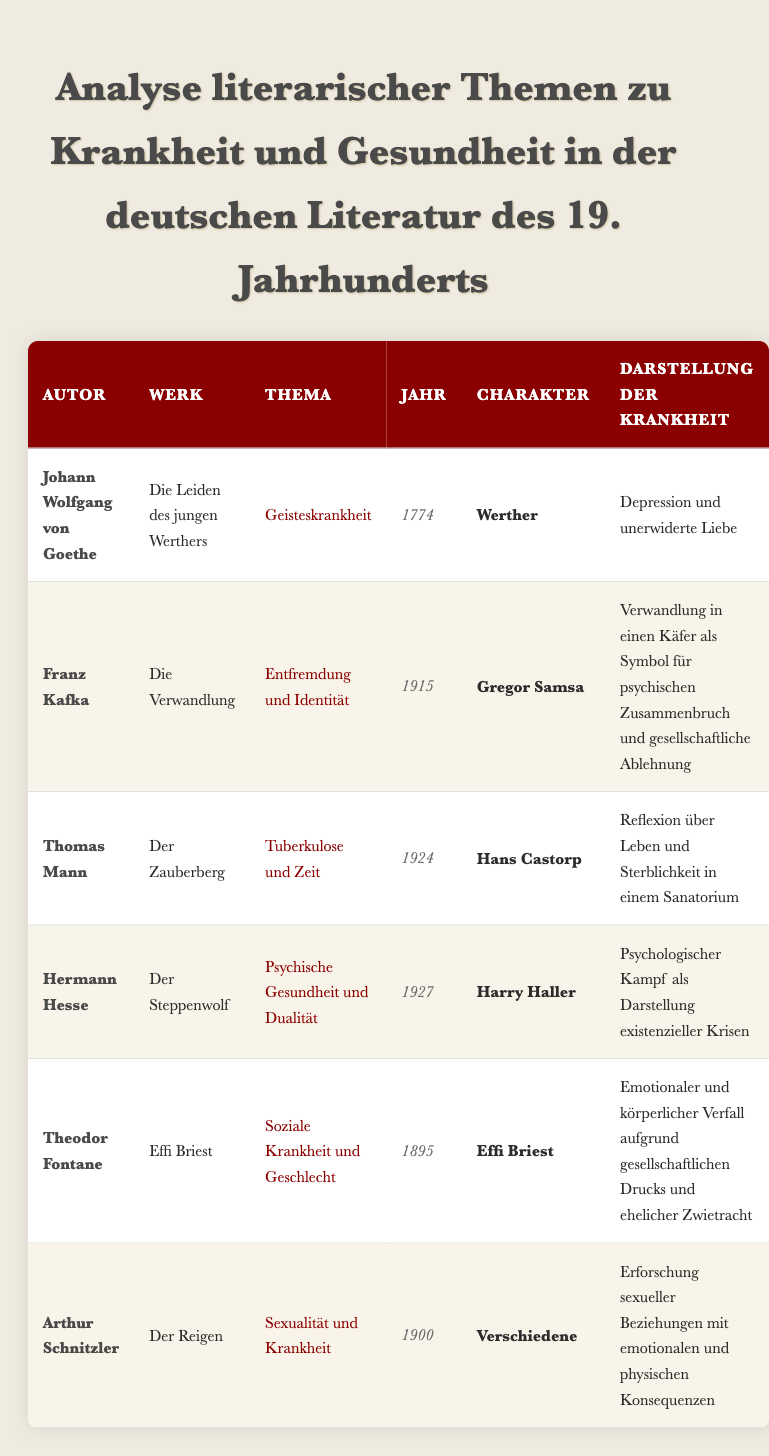What year was "The Metamorphosis" published? The table shows that "The Metamorphosis" was written by Franz Kafka and the corresponding year is listed as 1915.
Answer: 1915 Who is the main character in "Effi Briest"? According to the table, the character associated with "Effi Briest," written by Theodor Fontane, is Effi Briest herself.
Answer: Effi Briest Which author wrote about mental illness in the 18th century? The table indicates that Johann Wolfgang von Goethe wrote "The Sorrows of Young Werther" in 1774, which addresses mental illness.
Answer: Johann Wolfgang von Goethe Does "La Ronde" focus on themes of sexual relationships and their consequences? The entry for Arthur Schnitzler's "La Ronde" confirms that it explores sexual relationships leading to emotional and physical consequences.
Answer: Yes Which character in the table represents a psychological struggle? The character Harry Haller from Hermann Hesse's "Steppenwolf" is noted for representing a psychological struggle.
Answer: Harry Haller How many works listed in the table address the theme of mental illness? From the table, there are three works that address themes closely related to mental illness: "The Sorrows of Young Werther," "The Metamorphosis," and "Steppenwolf." Thus, the total is 3.
Answer: 3 Which author has the latest publication date in this list? By examining the publication years, "The Magic Mountain" by Thomas Mann (1924) has the latest year in the table, which is later than any other listed work.
Answer: 1924 What illness theme does Theodor Fontane address in "Effi Briest"? The table specifies that Theodor Fontane's "Effi Briest" addresses the theme of social illness and gender, showing how societal pressure affects the character.
Answer: Social Illness and Gender Does "The Magic Mountain" represent a reflection on mortality? The illness representation for "The Magic Mountain" notes that it reflects on life and mortality within a sanatorium setting, confirming the focus on mortality.
Answer: Yes 